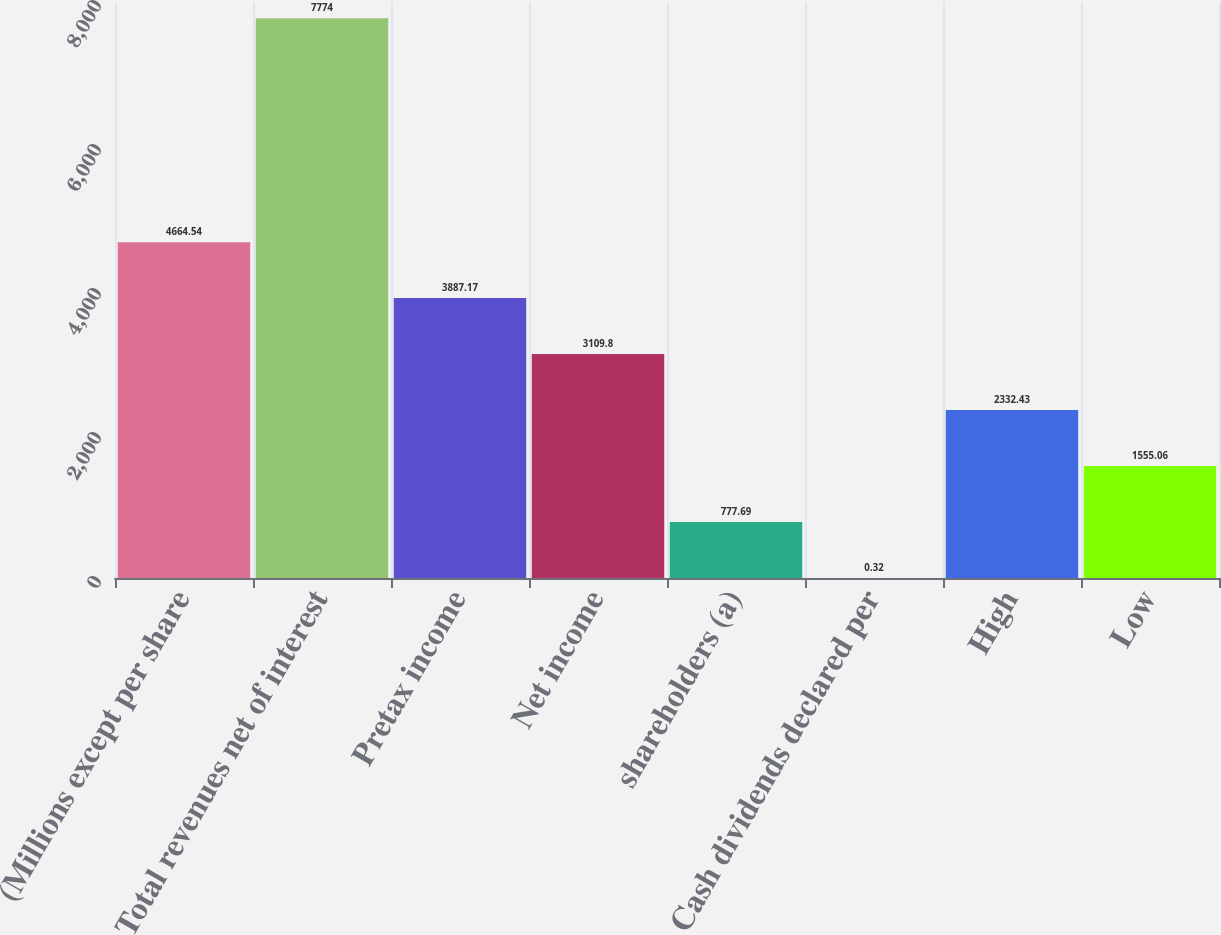<chart> <loc_0><loc_0><loc_500><loc_500><bar_chart><fcel>(Millions except per share<fcel>Total revenues net of interest<fcel>Pretax income<fcel>Net income<fcel>shareholders (a)<fcel>Cash dividends declared per<fcel>High<fcel>Low<nl><fcel>4664.54<fcel>7774<fcel>3887.17<fcel>3109.8<fcel>777.69<fcel>0.32<fcel>2332.43<fcel>1555.06<nl></chart> 